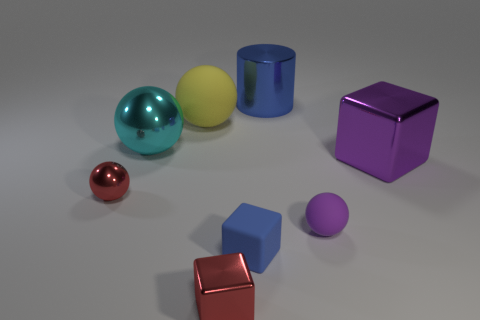Add 1 big blue balls. How many objects exist? 9 Subtract all cylinders. How many objects are left? 7 Add 5 blue things. How many blue things are left? 7 Add 5 big yellow metallic things. How many big yellow metallic things exist? 5 Subtract 1 red balls. How many objects are left? 7 Subtract all large yellow matte things. Subtract all purple objects. How many objects are left? 5 